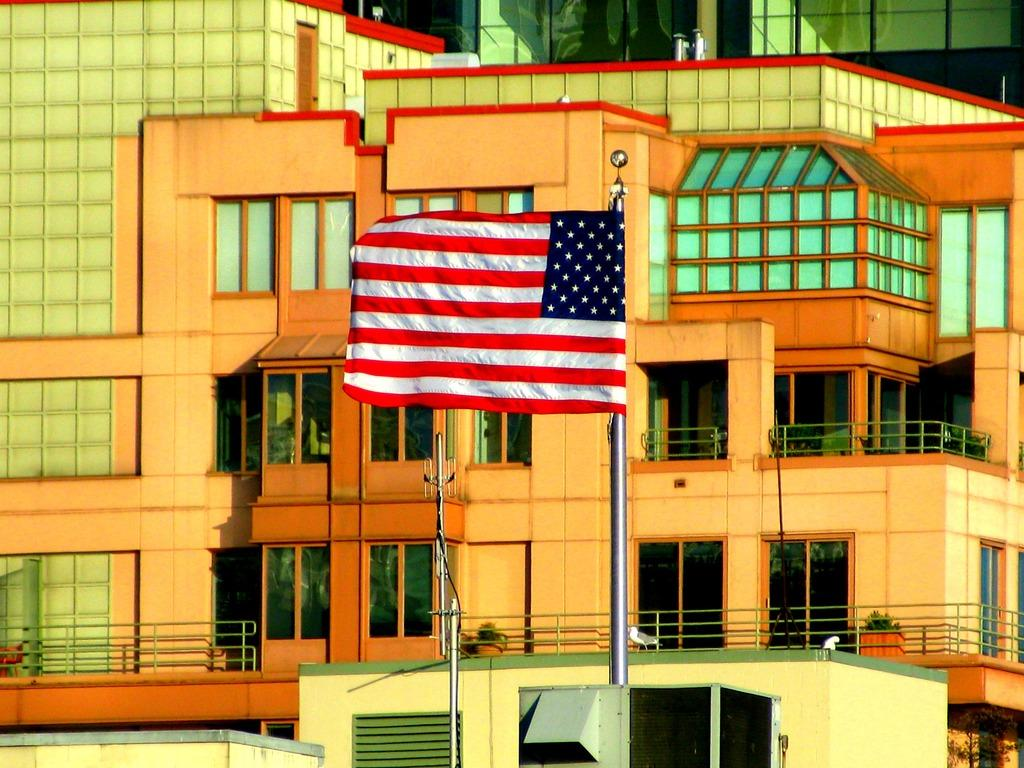What is the main subject in the middle of the image? There is a flag in the middle of the image. What can be seen at the bottom of the image? There are poles at the bottom of the image. What is visible in the background of the image? There is a building in the background of the image. How many cubs are playing with the cakes in the image? There are no cubs or cakes present in the image. What type of cattle can be seen grazing in the image? There is no cattle present in the image. 